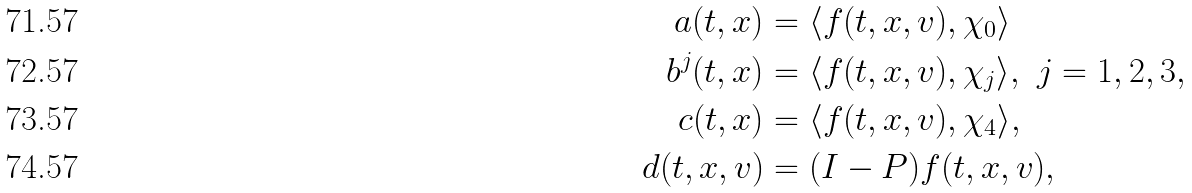Convert formula to latex. <formula><loc_0><loc_0><loc_500><loc_500>a ( t , x ) & = \langle f ( t , x , v ) , \chi _ { 0 } \rangle \\ b ^ { j } ( t , x ) & = \langle f ( t , x , v ) , \chi _ { j } \rangle , \ j = 1 , 2 , 3 , \\ c ( t , x ) & = \langle f ( t , x , v ) , \chi _ { 4 } \rangle , \\ d ( t , x , v ) & = ( I - P ) f ( t , x , v ) ,</formula> 